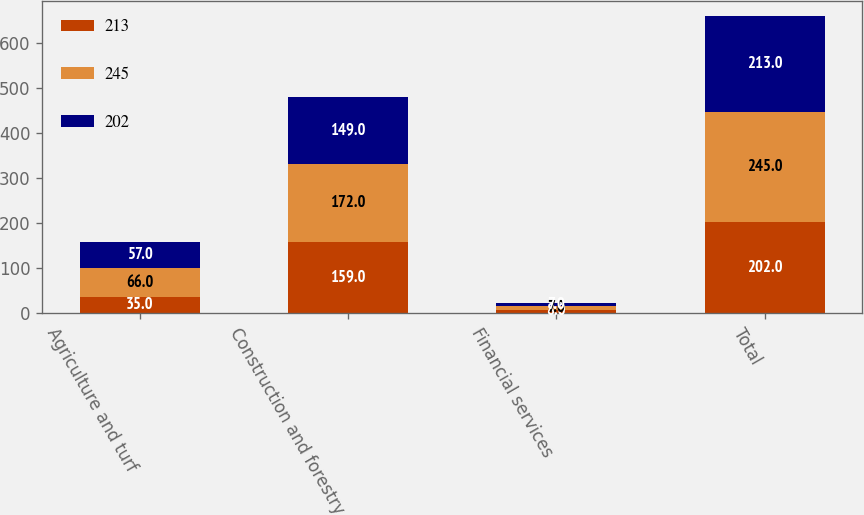Convert chart. <chart><loc_0><loc_0><loc_500><loc_500><stacked_bar_chart><ecel><fcel>Agriculture and turf<fcel>Construction and forestry<fcel>Financial services<fcel>Total<nl><fcel>213<fcel>35<fcel>159<fcel>8<fcel>202<nl><fcel>245<fcel>66<fcel>172<fcel>7<fcel>245<nl><fcel>202<fcel>57<fcel>149<fcel>7<fcel>213<nl></chart> 